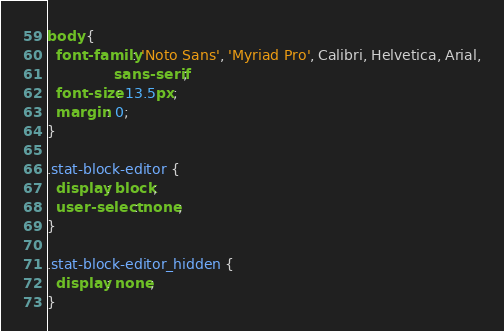Convert code to text. <code><loc_0><loc_0><loc_500><loc_500><_CSS_>body {
  font-family: 'Noto Sans', 'Myriad Pro', Calibri, Helvetica, Arial,
               sans-serif;
  font-size: 13.5px;
  margin: 0;
}

.stat-block-editor {
  display: block;
  user-select: none;
}

.stat-block-editor_hidden {
  display: none;
}
</code> 